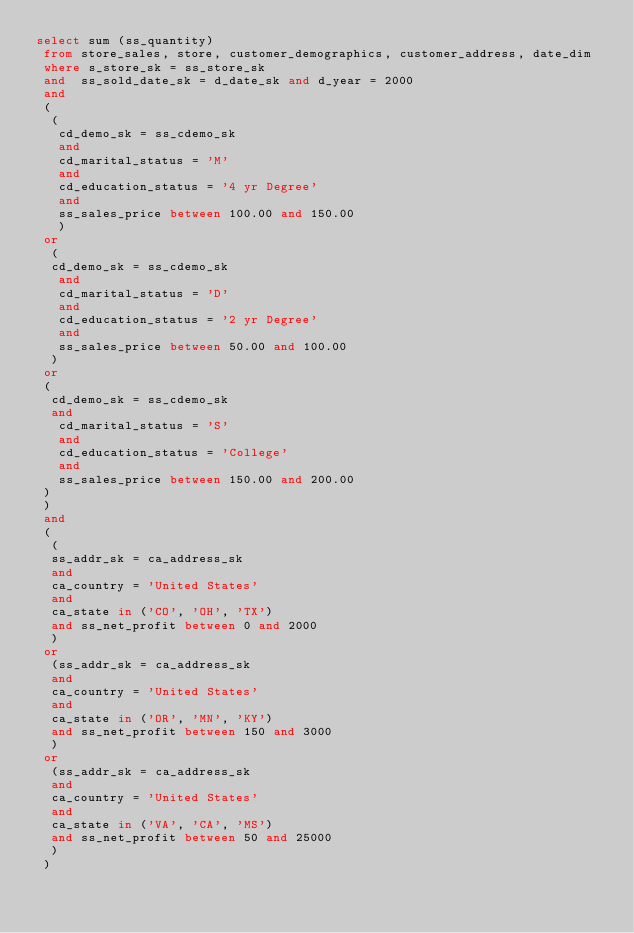<code> <loc_0><loc_0><loc_500><loc_500><_SQL_>select sum (ss_quantity)
 from store_sales, store, customer_demographics, customer_address, date_dim
 where s_store_sk = ss_store_sk
 and  ss_sold_date_sk = d_date_sk and d_year = 2000
 and  
 (
  (
   cd_demo_sk = ss_cdemo_sk
   and 
   cd_marital_status = 'M'
   and 
   cd_education_status = '4 yr Degree'
   and 
   ss_sales_price between 100.00 and 150.00  
   )
 or
  (
  cd_demo_sk = ss_cdemo_sk
   and 
   cd_marital_status = 'D'
   and 
   cd_education_status = '2 yr Degree'
   and 
   ss_sales_price between 50.00 and 100.00   
  )
 or 
 (
  cd_demo_sk = ss_cdemo_sk
  and 
   cd_marital_status = 'S'
   and 
   cd_education_status = 'College'
   and 
   ss_sales_price between 150.00 and 200.00  
 )
 )
 and
 (
  (
  ss_addr_sk = ca_address_sk
  and
  ca_country = 'United States'
  and
  ca_state in ('CO', 'OH', 'TX')
  and ss_net_profit between 0 and 2000  
  )
 or
  (ss_addr_sk = ca_address_sk
  and
  ca_country = 'United States'
  and
  ca_state in ('OR', 'MN', 'KY')
  and ss_net_profit between 150 and 3000 
  )
 or
  (ss_addr_sk = ca_address_sk
  and
  ca_country = 'United States'
  and
  ca_state in ('VA', 'CA', 'MS')
  and ss_net_profit between 50 and 25000 
  )
 )

</code> 